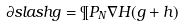<formula> <loc_0><loc_0><loc_500><loc_500>\partial s l a s h g = \P P _ { N } \nabla H ( g + h )</formula> 